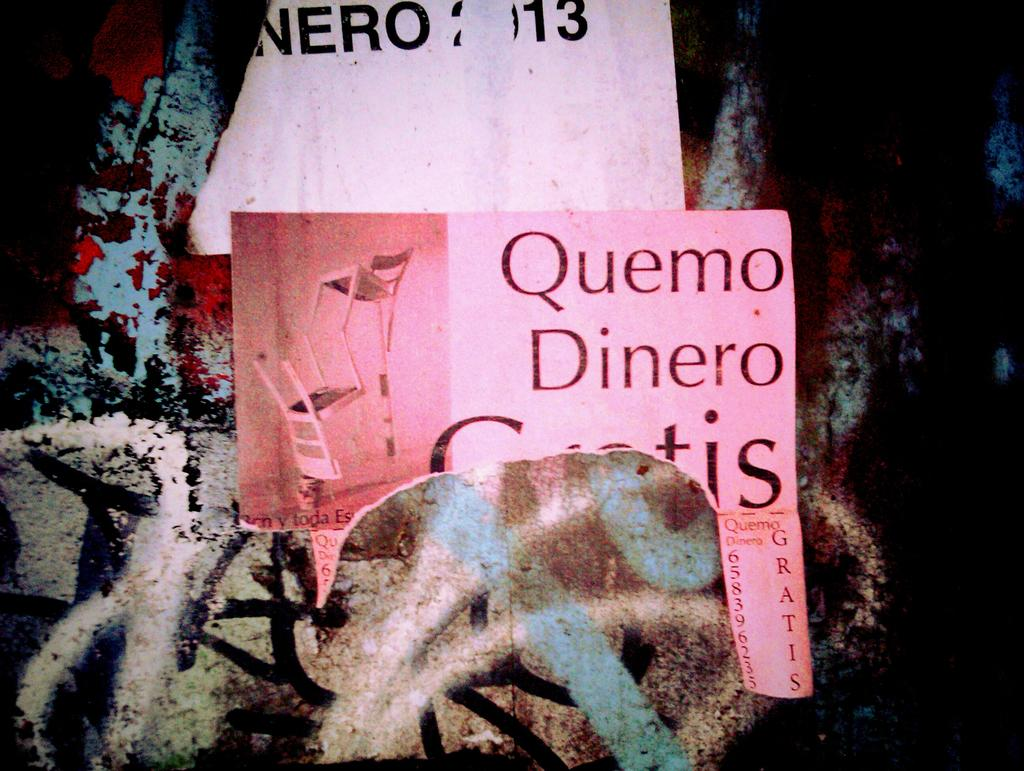What objects are on the wall in the foreground of the image? There are two papers on a wall in the foreground of the image. Can you describe the papers in more detail? Unfortunately, the details of the papers cannot be discerned from the image. What might be the purpose of the papers on the wall? The purpose of the papers on the wall is not clear from the image, but they could be posters, notices, or artwork. What type of sweater is being balanced on the edge of the papers in the image? There is no sweater present in the image, nor is anything being balanced on the edge of the papers. 